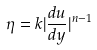Convert formula to latex. <formula><loc_0><loc_0><loc_500><loc_500>\eta = k | \frac { d u } { d y } | ^ { n - 1 }</formula> 